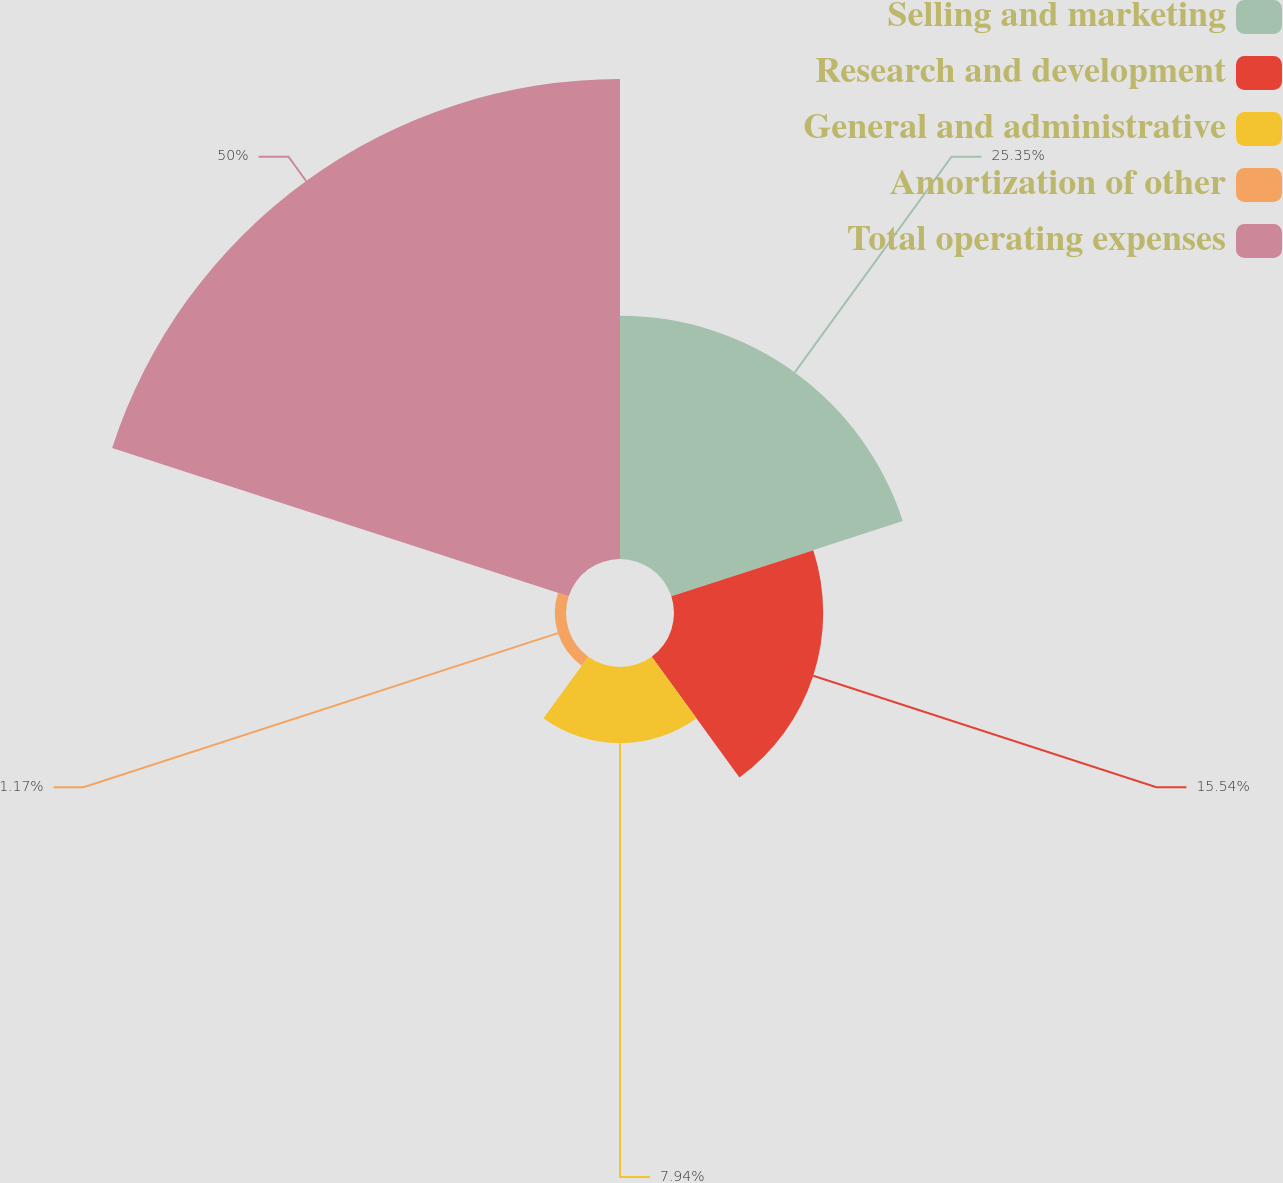Convert chart. <chart><loc_0><loc_0><loc_500><loc_500><pie_chart><fcel>Selling and marketing<fcel>Research and development<fcel>General and administrative<fcel>Amortization of other<fcel>Total operating expenses<nl><fcel>25.35%<fcel>15.54%<fcel>7.94%<fcel>1.17%<fcel>50.0%<nl></chart> 